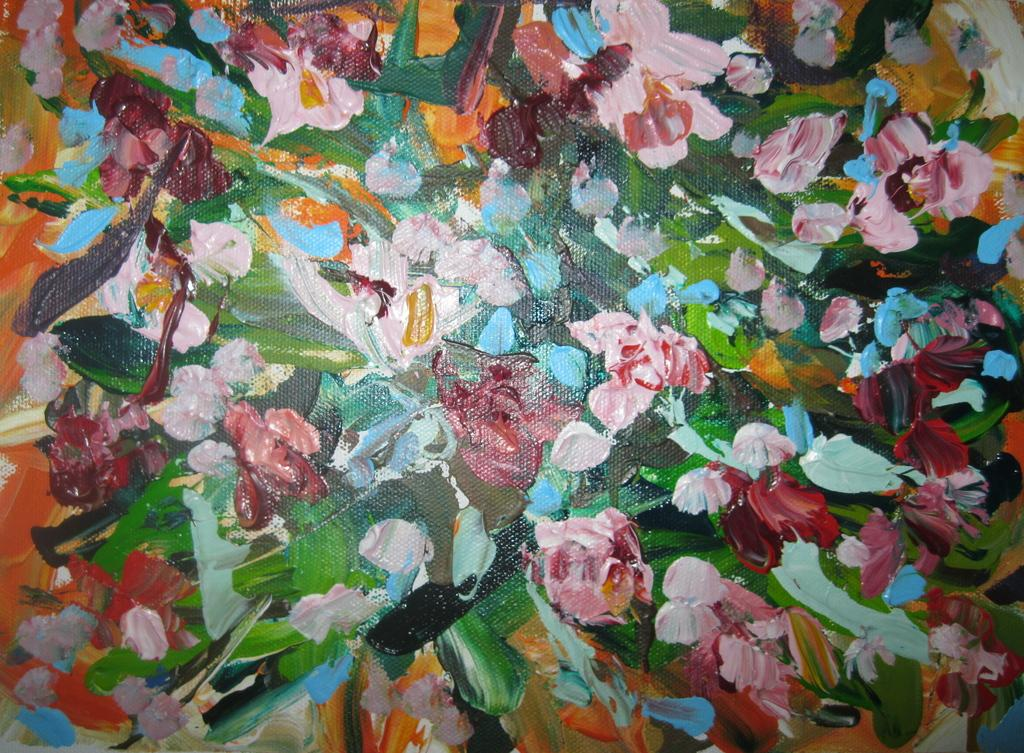What is the main subject in the image? There is a painting in the image. Can you describe the painting? The painting has different colors. How many sheep are running in the painting? There are no sheep or running depicted in the painting; it only has different colors. 